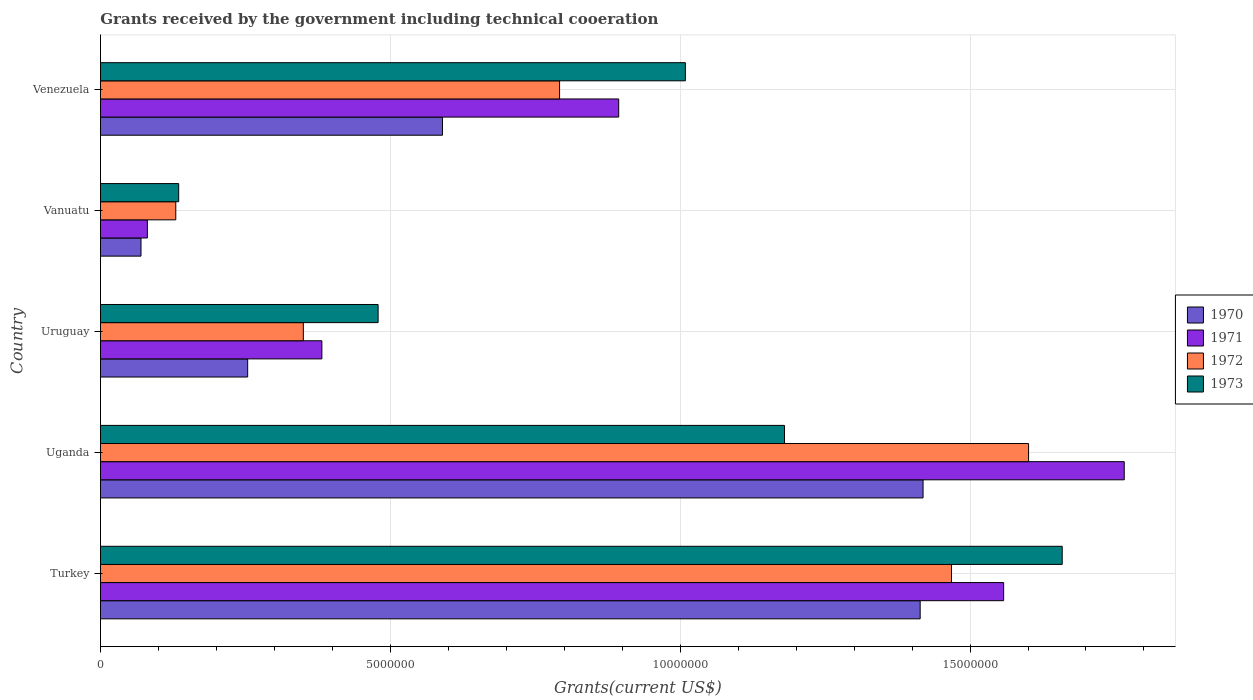How many groups of bars are there?
Make the answer very short. 5. Are the number of bars per tick equal to the number of legend labels?
Provide a short and direct response. Yes. How many bars are there on the 2nd tick from the top?
Offer a terse response. 4. How many bars are there on the 5th tick from the bottom?
Your answer should be very brief. 4. What is the label of the 2nd group of bars from the top?
Your answer should be very brief. Vanuatu. What is the total grants received by the government in 1973 in Turkey?
Offer a very short reply. 1.66e+07. Across all countries, what is the maximum total grants received by the government in 1971?
Your answer should be very brief. 1.77e+07. Across all countries, what is the minimum total grants received by the government in 1972?
Keep it short and to the point. 1.30e+06. In which country was the total grants received by the government in 1971 maximum?
Keep it short and to the point. Uganda. In which country was the total grants received by the government in 1970 minimum?
Give a very brief answer. Vanuatu. What is the total total grants received by the government in 1971 in the graph?
Provide a short and direct response. 4.68e+07. What is the difference between the total grants received by the government in 1971 in Uruguay and that in Venezuela?
Provide a short and direct response. -5.12e+06. What is the difference between the total grants received by the government in 1971 in Turkey and the total grants received by the government in 1972 in Uganda?
Provide a succinct answer. -4.30e+05. What is the average total grants received by the government in 1970 per country?
Offer a very short reply. 7.49e+06. What is the difference between the total grants received by the government in 1972 and total grants received by the government in 1970 in Uganda?
Your response must be concise. 1.82e+06. In how many countries, is the total grants received by the government in 1970 greater than 2000000 US$?
Your answer should be very brief. 4. What is the ratio of the total grants received by the government in 1970 in Uganda to that in Venezuela?
Offer a very short reply. 2.41. What is the difference between the highest and the second highest total grants received by the government in 1971?
Keep it short and to the point. 2.08e+06. What is the difference between the highest and the lowest total grants received by the government in 1973?
Ensure brevity in your answer.  1.52e+07. In how many countries, is the total grants received by the government in 1973 greater than the average total grants received by the government in 1973 taken over all countries?
Provide a succinct answer. 3. Is the sum of the total grants received by the government in 1973 in Turkey and Venezuela greater than the maximum total grants received by the government in 1971 across all countries?
Offer a very short reply. Yes. Are all the bars in the graph horizontal?
Your answer should be compact. Yes. How many countries are there in the graph?
Provide a succinct answer. 5. What is the difference between two consecutive major ticks on the X-axis?
Your answer should be very brief. 5.00e+06. Are the values on the major ticks of X-axis written in scientific E-notation?
Ensure brevity in your answer.  No. How many legend labels are there?
Keep it short and to the point. 4. How are the legend labels stacked?
Your answer should be compact. Vertical. What is the title of the graph?
Your answer should be compact. Grants received by the government including technical cooeration. Does "2001" appear as one of the legend labels in the graph?
Your answer should be very brief. No. What is the label or title of the X-axis?
Ensure brevity in your answer.  Grants(current US$). What is the label or title of the Y-axis?
Your answer should be very brief. Country. What is the Grants(current US$) in 1970 in Turkey?
Your answer should be very brief. 1.41e+07. What is the Grants(current US$) of 1971 in Turkey?
Keep it short and to the point. 1.56e+07. What is the Grants(current US$) of 1972 in Turkey?
Your answer should be very brief. 1.47e+07. What is the Grants(current US$) in 1973 in Turkey?
Make the answer very short. 1.66e+07. What is the Grants(current US$) in 1970 in Uganda?
Offer a very short reply. 1.42e+07. What is the Grants(current US$) of 1971 in Uganda?
Make the answer very short. 1.77e+07. What is the Grants(current US$) of 1972 in Uganda?
Make the answer very short. 1.60e+07. What is the Grants(current US$) of 1973 in Uganda?
Your answer should be very brief. 1.18e+07. What is the Grants(current US$) in 1970 in Uruguay?
Provide a short and direct response. 2.54e+06. What is the Grants(current US$) in 1971 in Uruguay?
Offer a terse response. 3.82e+06. What is the Grants(current US$) in 1972 in Uruguay?
Your answer should be very brief. 3.50e+06. What is the Grants(current US$) of 1973 in Uruguay?
Keep it short and to the point. 4.79e+06. What is the Grants(current US$) of 1970 in Vanuatu?
Your response must be concise. 7.00e+05. What is the Grants(current US$) of 1971 in Vanuatu?
Your response must be concise. 8.10e+05. What is the Grants(current US$) in 1972 in Vanuatu?
Provide a short and direct response. 1.30e+06. What is the Grants(current US$) in 1973 in Vanuatu?
Provide a short and direct response. 1.35e+06. What is the Grants(current US$) in 1970 in Venezuela?
Keep it short and to the point. 5.90e+06. What is the Grants(current US$) in 1971 in Venezuela?
Provide a short and direct response. 8.94e+06. What is the Grants(current US$) of 1972 in Venezuela?
Provide a succinct answer. 7.92e+06. What is the Grants(current US$) of 1973 in Venezuela?
Provide a succinct answer. 1.01e+07. Across all countries, what is the maximum Grants(current US$) in 1970?
Offer a terse response. 1.42e+07. Across all countries, what is the maximum Grants(current US$) of 1971?
Offer a very short reply. 1.77e+07. Across all countries, what is the maximum Grants(current US$) in 1972?
Give a very brief answer. 1.60e+07. Across all countries, what is the maximum Grants(current US$) of 1973?
Give a very brief answer. 1.66e+07. Across all countries, what is the minimum Grants(current US$) in 1971?
Offer a terse response. 8.10e+05. Across all countries, what is the minimum Grants(current US$) in 1972?
Provide a short and direct response. 1.30e+06. Across all countries, what is the minimum Grants(current US$) of 1973?
Your answer should be very brief. 1.35e+06. What is the total Grants(current US$) of 1970 in the graph?
Ensure brevity in your answer.  3.75e+07. What is the total Grants(current US$) in 1971 in the graph?
Your answer should be compact. 4.68e+07. What is the total Grants(current US$) of 1972 in the graph?
Provide a short and direct response. 4.34e+07. What is the total Grants(current US$) of 1973 in the graph?
Offer a terse response. 4.46e+07. What is the difference between the Grants(current US$) in 1971 in Turkey and that in Uganda?
Make the answer very short. -2.08e+06. What is the difference between the Grants(current US$) in 1972 in Turkey and that in Uganda?
Provide a succinct answer. -1.33e+06. What is the difference between the Grants(current US$) of 1973 in Turkey and that in Uganda?
Ensure brevity in your answer.  4.79e+06. What is the difference between the Grants(current US$) in 1970 in Turkey and that in Uruguay?
Offer a very short reply. 1.16e+07. What is the difference between the Grants(current US$) in 1971 in Turkey and that in Uruguay?
Offer a very short reply. 1.18e+07. What is the difference between the Grants(current US$) in 1972 in Turkey and that in Uruguay?
Ensure brevity in your answer.  1.12e+07. What is the difference between the Grants(current US$) of 1973 in Turkey and that in Uruguay?
Ensure brevity in your answer.  1.18e+07. What is the difference between the Grants(current US$) of 1970 in Turkey and that in Vanuatu?
Keep it short and to the point. 1.34e+07. What is the difference between the Grants(current US$) in 1971 in Turkey and that in Vanuatu?
Offer a terse response. 1.48e+07. What is the difference between the Grants(current US$) of 1972 in Turkey and that in Vanuatu?
Your answer should be compact. 1.34e+07. What is the difference between the Grants(current US$) in 1973 in Turkey and that in Vanuatu?
Your response must be concise. 1.52e+07. What is the difference between the Grants(current US$) of 1970 in Turkey and that in Venezuela?
Offer a very short reply. 8.24e+06. What is the difference between the Grants(current US$) of 1971 in Turkey and that in Venezuela?
Ensure brevity in your answer.  6.64e+06. What is the difference between the Grants(current US$) of 1972 in Turkey and that in Venezuela?
Your answer should be very brief. 6.76e+06. What is the difference between the Grants(current US$) of 1973 in Turkey and that in Venezuela?
Your answer should be very brief. 6.50e+06. What is the difference between the Grants(current US$) in 1970 in Uganda and that in Uruguay?
Give a very brief answer. 1.16e+07. What is the difference between the Grants(current US$) of 1971 in Uganda and that in Uruguay?
Make the answer very short. 1.38e+07. What is the difference between the Grants(current US$) in 1972 in Uganda and that in Uruguay?
Your answer should be compact. 1.25e+07. What is the difference between the Grants(current US$) in 1973 in Uganda and that in Uruguay?
Offer a terse response. 7.01e+06. What is the difference between the Grants(current US$) in 1970 in Uganda and that in Vanuatu?
Ensure brevity in your answer.  1.35e+07. What is the difference between the Grants(current US$) in 1971 in Uganda and that in Vanuatu?
Give a very brief answer. 1.68e+07. What is the difference between the Grants(current US$) of 1972 in Uganda and that in Vanuatu?
Give a very brief answer. 1.47e+07. What is the difference between the Grants(current US$) in 1973 in Uganda and that in Vanuatu?
Provide a succinct answer. 1.04e+07. What is the difference between the Grants(current US$) of 1970 in Uganda and that in Venezuela?
Make the answer very short. 8.29e+06. What is the difference between the Grants(current US$) in 1971 in Uganda and that in Venezuela?
Ensure brevity in your answer.  8.72e+06. What is the difference between the Grants(current US$) of 1972 in Uganda and that in Venezuela?
Your response must be concise. 8.09e+06. What is the difference between the Grants(current US$) in 1973 in Uganda and that in Venezuela?
Offer a terse response. 1.71e+06. What is the difference between the Grants(current US$) in 1970 in Uruguay and that in Vanuatu?
Provide a succinct answer. 1.84e+06. What is the difference between the Grants(current US$) in 1971 in Uruguay and that in Vanuatu?
Keep it short and to the point. 3.01e+06. What is the difference between the Grants(current US$) of 1972 in Uruguay and that in Vanuatu?
Keep it short and to the point. 2.20e+06. What is the difference between the Grants(current US$) in 1973 in Uruguay and that in Vanuatu?
Offer a very short reply. 3.44e+06. What is the difference between the Grants(current US$) of 1970 in Uruguay and that in Venezuela?
Ensure brevity in your answer.  -3.36e+06. What is the difference between the Grants(current US$) of 1971 in Uruguay and that in Venezuela?
Make the answer very short. -5.12e+06. What is the difference between the Grants(current US$) in 1972 in Uruguay and that in Venezuela?
Make the answer very short. -4.42e+06. What is the difference between the Grants(current US$) of 1973 in Uruguay and that in Venezuela?
Offer a terse response. -5.30e+06. What is the difference between the Grants(current US$) of 1970 in Vanuatu and that in Venezuela?
Provide a succinct answer. -5.20e+06. What is the difference between the Grants(current US$) of 1971 in Vanuatu and that in Venezuela?
Ensure brevity in your answer.  -8.13e+06. What is the difference between the Grants(current US$) in 1972 in Vanuatu and that in Venezuela?
Give a very brief answer. -6.62e+06. What is the difference between the Grants(current US$) of 1973 in Vanuatu and that in Venezuela?
Your response must be concise. -8.74e+06. What is the difference between the Grants(current US$) in 1970 in Turkey and the Grants(current US$) in 1971 in Uganda?
Provide a succinct answer. -3.52e+06. What is the difference between the Grants(current US$) of 1970 in Turkey and the Grants(current US$) of 1972 in Uganda?
Provide a succinct answer. -1.87e+06. What is the difference between the Grants(current US$) of 1970 in Turkey and the Grants(current US$) of 1973 in Uganda?
Offer a very short reply. 2.34e+06. What is the difference between the Grants(current US$) in 1971 in Turkey and the Grants(current US$) in 1972 in Uganda?
Ensure brevity in your answer.  -4.30e+05. What is the difference between the Grants(current US$) in 1971 in Turkey and the Grants(current US$) in 1973 in Uganda?
Your response must be concise. 3.78e+06. What is the difference between the Grants(current US$) of 1972 in Turkey and the Grants(current US$) of 1973 in Uganda?
Provide a short and direct response. 2.88e+06. What is the difference between the Grants(current US$) of 1970 in Turkey and the Grants(current US$) of 1971 in Uruguay?
Give a very brief answer. 1.03e+07. What is the difference between the Grants(current US$) in 1970 in Turkey and the Grants(current US$) in 1972 in Uruguay?
Give a very brief answer. 1.06e+07. What is the difference between the Grants(current US$) in 1970 in Turkey and the Grants(current US$) in 1973 in Uruguay?
Your response must be concise. 9.35e+06. What is the difference between the Grants(current US$) in 1971 in Turkey and the Grants(current US$) in 1972 in Uruguay?
Give a very brief answer. 1.21e+07. What is the difference between the Grants(current US$) of 1971 in Turkey and the Grants(current US$) of 1973 in Uruguay?
Offer a very short reply. 1.08e+07. What is the difference between the Grants(current US$) in 1972 in Turkey and the Grants(current US$) in 1973 in Uruguay?
Your response must be concise. 9.89e+06. What is the difference between the Grants(current US$) in 1970 in Turkey and the Grants(current US$) in 1971 in Vanuatu?
Provide a succinct answer. 1.33e+07. What is the difference between the Grants(current US$) of 1970 in Turkey and the Grants(current US$) of 1972 in Vanuatu?
Keep it short and to the point. 1.28e+07. What is the difference between the Grants(current US$) in 1970 in Turkey and the Grants(current US$) in 1973 in Vanuatu?
Your answer should be very brief. 1.28e+07. What is the difference between the Grants(current US$) of 1971 in Turkey and the Grants(current US$) of 1972 in Vanuatu?
Offer a terse response. 1.43e+07. What is the difference between the Grants(current US$) in 1971 in Turkey and the Grants(current US$) in 1973 in Vanuatu?
Give a very brief answer. 1.42e+07. What is the difference between the Grants(current US$) of 1972 in Turkey and the Grants(current US$) of 1973 in Vanuatu?
Provide a succinct answer. 1.33e+07. What is the difference between the Grants(current US$) in 1970 in Turkey and the Grants(current US$) in 1971 in Venezuela?
Provide a short and direct response. 5.20e+06. What is the difference between the Grants(current US$) in 1970 in Turkey and the Grants(current US$) in 1972 in Venezuela?
Keep it short and to the point. 6.22e+06. What is the difference between the Grants(current US$) in 1970 in Turkey and the Grants(current US$) in 1973 in Venezuela?
Keep it short and to the point. 4.05e+06. What is the difference between the Grants(current US$) in 1971 in Turkey and the Grants(current US$) in 1972 in Venezuela?
Your answer should be very brief. 7.66e+06. What is the difference between the Grants(current US$) of 1971 in Turkey and the Grants(current US$) of 1973 in Venezuela?
Your response must be concise. 5.49e+06. What is the difference between the Grants(current US$) in 1972 in Turkey and the Grants(current US$) in 1973 in Venezuela?
Offer a terse response. 4.59e+06. What is the difference between the Grants(current US$) in 1970 in Uganda and the Grants(current US$) in 1971 in Uruguay?
Offer a very short reply. 1.04e+07. What is the difference between the Grants(current US$) in 1970 in Uganda and the Grants(current US$) in 1972 in Uruguay?
Your answer should be very brief. 1.07e+07. What is the difference between the Grants(current US$) of 1970 in Uganda and the Grants(current US$) of 1973 in Uruguay?
Your response must be concise. 9.40e+06. What is the difference between the Grants(current US$) of 1971 in Uganda and the Grants(current US$) of 1972 in Uruguay?
Make the answer very short. 1.42e+07. What is the difference between the Grants(current US$) in 1971 in Uganda and the Grants(current US$) in 1973 in Uruguay?
Ensure brevity in your answer.  1.29e+07. What is the difference between the Grants(current US$) of 1972 in Uganda and the Grants(current US$) of 1973 in Uruguay?
Provide a short and direct response. 1.12e+07. What is the difference between the Grants(current US$) of 1970 in Uganda and the Grants(current US$) of 1971 in Vanuatu?
Make the answer very short. 1.34e+07. What is the difference between the Grants(current US$) in 1970 in Uganda and the Grants(current US$) in 1972 in Vanuatu?
Your response must be concise. 1.29e+07. What is the difference between the Grants(current US$) of 1970 in Uganda and the Grants(current US$) of 1973 in Vanuatu?
Offer a very short reply. 1.28e+07. What is the difference between the Grants(current US$) in 1971 in Uganda and the Grants(current US$) in 1972 in Vanuatu?
Offer a terse response. 1.64e+07. What is the difference between the Grants(current US$) in 1971 in Uganda and the Grants(current US$) in 1973 in Vanuatu?
Provide a succinct answer. 1.63e+07. What is the difference between the Grants(current US$) in 1972 in Uganda and the Grants(current US$) in 1973 in Vanuatu?
Provide a short and direct response. 1.47e+07. What is the difference between the Grants(current US$) in 1970 in Uganda and the Grants(current US$) in 1971 in Venezuela?
Keep it short and to the point. 5.25e+06. What is the difference between the Grants(current US$) in 1970 in Uganda and the Grants(current US$) in 1972 in Venezuela?
Ensure brevity in your answer.  6.27e+06. What is the difference between the Grants(current US$) of 1970 in Uganda and the Grants(current US$) of 1973 in Venezuela?
Make the answer very short. 4.10e+06. What is the difference between the Grants(current US$) of 1971 in Uganda and the Grants(current US$) of 1972 in Venezuela?
Offer a very short reply. 9.74e+06. What is the difference between the Grants(current US$) in 1971 in Uganda and the Grants(current US$) in 1973 in Venezuela?
Give a very brief answer. 7.57e+06. What is the difference between the Grants(current US$) in 1972 in Uganda and the Grants(current US$) in 1973 in Venezuela?
Make the answer very short. 5.92e+06. What is the difference between the Grants(current US$) in 1970 in Uruguay and the Grants(current US$) in 1971 in Vanuatu?
Keep it short and to the point. 1.73e+06. What is the difference between the Grants(current US$) of 1970 in Uruguay and the Grants(current US$) of 1972 in Vanuatu?
Offer a terse response. 1.24e+06. What is the difference between the Grants(current US$) of 1970 in Uruguay and the Grants(current US$) of 1973 in Vanuatu?
Your response must be concise. 1.19e+06. What is the difference between the Grants(current US$) of 1971 in Uruguay and the Grants(current US$) of 1972 in Vanuatu?
Offer a terse response. 2.52e+06. What is the difference between the Grants(current US$) in 1971 in Uruguay and the Grants(current US$) in 1973 in Vanuatu?
Ensure brevity in your answer.  2.47e+06. What is the difference between the Grants(current US$) in 1972 in Uruguay and the Grants(current US$) in 1973 in Vanuatu?
Your response must be concise. 2.15e+06. What is the difference between the Grants(current US$) in 1970 in Uruguay and the Grants(current US$) in 1971 in Venezuela?
Provide a short and direct response. -6.40e+06. What is the difference between the Grants(current US$) of 1970 in Uruguay and the Grants(current US$) of 1972 in Venezuela?
Your answer should be compact. -5.38e+06. What is the difference between the Grants(current US$) in 1970 in Uruguay and the Grants(current US$) in 1973 in Venezuela?
Make the answer very short. -7.55e+06. What is the difference between the Grants(current US$) in 1971 in Uruguay and the Grants(current US$) in 1972 in Venezuela?
Provide a short and direct response. -4.10e+06. What is the difference between the Grants(current US$) in 1971 in Uruguay and the Grants(current US$) in 1973 in Venezuela?
Your answer should be compact. -6.27e+06. What is the difference between the Grants(current US$) of 1972 in Uruguay and the Grants(current US$) of 1973 in Venezuela?
Provide a succinct answer. -6.59e+06. What is the difference between the Grants(current US$) of 1970 in Vanuatu and the Grants(current US$) of 1971 in Venezuela?
Offer a very short reply. -8.24e+06. What is the difference between the Grants(current US$) in 1970 in Vanuatu and the Grants(current US$) in 1972 in Venezuela?
Keep it short and to the point. -7.22e+06. What is the difference between the Grants(current US$) in 1970 in Vanuatu and the Grants(current US$) in 1973 in Venezuela?
Your answer should be compact. -9.39e+06. What is the difference between the Grants(current US$) of 1971 in Vanuatu and the Grants(current US$) of 1972 in Venezuela?
Provide a succinct answer. -7.11e+06. What is the difference between the Grants(current US$) in 1971 in Vanuatu and the Grants(current US$) in 1973 in Venezuela?
Offer a terse response. -9.28e+06. What is the difference between the Grants(current US$) of 1972 in Vanuatu and the Grants(current US$) of 1973 in Venezuela?
Your answer should be compact. -8.79e+06. What is the average Grants(current US$) of 1970 per country?
Give a very brief answer. 7.49e+06. What is the average Grants(current US$) in 1971 per country?
Make the answer very short. 9.36e+06. What is the average Grants(current US$) in 1972 per country?
Provide a short and direct response. 8.68e+06. What is the average Grants(current US$) in 1973 per country?
Ensure brevity in your answer.  8.92e+06. What is the difference between the Grants(current US$) of 1970 and Grants(current US$) of 1971 in Turkey?
Your response must be concise. -1.44e+06. What is the difference between the Grants(current US$) of 1970 and Grants(current US$) of 1972 in Turkey?
Give a very brief answer. -5.40e+05. What is the difference between the Grants(current US$) of 1970 and Grants(current US$) of 1973 in Turkey?
Offer a very short reply. -2.45e+06. What is the difference between the Grants(current US$) in 1971 and Grants(current US$) in 1973 in Turkey?
Give a very brief answer. -1.01e+06. What is the difference between the Grants(current US$) in 1972 and Grants(current US$) in 1973 in Turkey?
Provide a short and direct response. -1.91e+06. What is the difference between the Grants(current US$) in 1970 and Grants(current US$) in 1971 in Uganda?
Offer a terse response. -3.47e+06. What is the difference between the Grants(current US$) of 1970 and Grants(current US$) of 1972 in Uganda?
Offer a very short reply. -1.82e+06. What is the difference between the Grants(current US$) in 1970 and Grants(current US$) in 1973 in Uganda?
Keep it short and to the point. 2.39e+06. What is the difference between the Grants(current US$) of 1971 and Grants(current US$) of 1972 in Uganda?
Make the answer very short. 1.65e+06. What is the difference between the Grants(current US$) of 1971 and Grants(current US$) of 1973 in Uganda?
Your answer should be compact. 5.86e+06. What is the difference between the Grants(current US$) of 1972 and Grants(current US$) of 1973 in Uganda?
Provide a short and direct response. 4.21e+06. What is the difference between the Grants(current US$) of 1970 and Grants(current US$) of 1971 in Uruguay?
Keep it short and to the point. -1.28e+06. What is the difference between the Grants(current US$) in 1970 and Grants(current US$) in 1972 in Uruguay?
Provide a succinct answer. -9.60e+05. What is the difference between the Grants(current US$) in 1970 and Grants(current US$) in 1973 in Uruguay?
Your response must be concise. -2.25e+06. What is the difference between the Grants(current US$) of 1971 and Grants(current US$) of 1972 in Uruguay?
Offer a very short reply. 3.20e+05. What is the difference between the Grants(current US$) in 1971 and Grants(current US$) in 1973 in Uruguay?
Keep it short and to the point. -9.70e+05. What is the difference between the Grants(current US$) in 1972 and Grants(current US$) in 1973 in Uruguay?
Make the answer very short. -1.29e+06. What is the difference between the Grants(current US$) of 1970 and Grants(current US$) of 1971 in Vanuatu?
Make the answer very short. -1.10e+05. What is the difference between the Grants(current US$) of 1970 and Grants(current US$) of 1972 in Vanuatu?
Offer a very short reply. -6.00e+05. What is the difference between the Grants(current US$) in 1970 and Grants(current US$) in 1973 in Vanuatu?
Keep it short and to the point. -6.50e+05. What is the difference between the Grants(current US$) in 1971 and Grants(current US$) in 1972 in Vanuatu?
Offer a very short reply. -4.90e+05. What is the difference between the Grants(current US$) in 1971 and Grants(current US$) in 1973 in Vanuatu?
Ensure brevity in your answer.  -5.40e+05. What is the difference between the Grants(current US$) in 1970 and Grants(current US$) in 1971 in Venezuela?
Make the answer very short. -3.04e+06. What is the difference between the Grants(current US$) in 1970 and Grants(current US$) in 1972 in Venezuela?
Keep it short and to the point. -2.02e+06. What is the difference between the Grants(current US$) of 1970 and Grants(current US$) of 1973 in Venezuela?
Offer a very short reply. -4.19e+06. What is the difference between the Grants(current US$) in 1971 and Grants(current US$) in 1972 in Venezuela?
Your response must be concise. 1.02e+06. What is the difference between the Grants(current US$) in 1971 and Grants(current US$) in 1973 in Venezuela?
Provide a succinct answer. -1.15e+06. What is the difference between the Grants(current US$) of 1972 and Grants(current US$) of 1973 in Venezuela?
Your response must be concise. -2.17e+06. What is the ratio of the Grants(current US$) of 1971 in Turkey to that in Uganda?
Provide a succinct answer. 0.88. What is the ratio of the Grants(current US$) of 1972 in Turkey to that in Uganda?
Keep it short and to the point. 0.92. What is the ratio of the Grants(current US$) in 1973 in Turkey to that in Uganda?
Your answer should be compact. 1.41. What is the ratio of the Grants(current US$) of 1970 in Turkey to that in Uruguay?
Offer a very short reply. 5.57. What is the ratio of the Grants(current US$) in 1971 in Turkey to that in Uruguay?
Make the answer very short. 4.08. What is the ratio of the Grants(current US$) of 1972 in Turkey to that in Uruguay?
Your response must be concise. 4.19. What is the ratio of the Grants(current US$) in 1973 in Turkey to that in Uruguay?
Provide a succinct answer. 3.46. What is the ratio of the Grants(current US$) in 1970 in Turkey to that in Vanuatu?
Offer a terse response. 20.2. What is the ratio of the Grants(current US$) of 1971 in Turkey to that in Vanuatu?
Keep it short and to the point. 19.23. What is the ratio of the Grants(current US$) in 1972 in Turkey to that in Vanuatu?
Offer a terse response. 11.29. What is the ratio of the Grants(current US$) of 1973 in Turkey to that in Vanuatu?
Your answer should be compact. 12.29. What is the ratio of the Grants(current US$) of 1970 in Turkey to that in Venezuela?
Provide a succinct answer. 2.4. What is the ratio of the Grants(current US$) of 1971 in Turkey to that in Venezuela?
Your answer should be compact. 1.74. What is the ratio of the Grants(current US$) in 1972 in Turkey to that in Venezuela?
Offer a very short reply. 1.85. What is the ratio of the Grants(current US$) in 1973 in Turkey to that in Venezuela?
Your response must be concise. 1.64. What is the ratio of the Grants(current US$) of 1970 in Uganda to that in Uruguay?
Your answer should be compact. 5.59. What is the ratio of the Grants(current US$) in 1971 in Uganda to that in Uruguay?
Offer a terse response. 4.62. What is the ratio of the Grants(current US$) of 1972 in Uganda to that in Uruguay?
Provide a short and direct response. 4.57. What is the ratio of the Grants(current US$) of 1973 in Uganda to that in Uruguay?
Make the answer very short. 2.46. What is the ratio of the Grants(current US$) in 1970 in Uganda to that in Vanuatu?
Give a very brief answer. 20.27. What is the ratio of the Grants(current US$) in 1971 in Uganda to that in Vanuatu?
Provide a short and direct response. 21.8. What is the ratio of the Grants(current US$) of 1972 in Uganda to that in Vanuatu?
Offer a very short reply. 12.32. What is the ratio of the Grants(current US$) in 1973 in Uganda to that in Vanuatu?
Your answer should be compact. 8.74. What is the ratio of the Grants(current US$) in 1970 in Uganda to that in Venezuela?
Keep it short and to the point. 2.41. What is the ratio of the Grants(current US$) of 1971 in Uganda to that in Venezuela?
Offer a very short reply. 1.98. What is the ratio of the Grants(current US$) of 1972 in Uganda to that in Venezuela?
Offer a terse response. 2.02. What is the ratio of the Grants(current US$) of 1973 in Uganda to that in Venezuela?
Your answer should be very brief. 1.17. What is the ratio of the Grants(current US$) of 1970 in Uruguay to that in Vanuatu?
Your response must be concise. 3.63. What is the ratio of the Grants(current US$) of 1971 in Uruguay to that in Vanuatu?
Provide a succinct answer. 4.72. What is the ratio of the Grants(current US$) in 1972 in Uruguay to that in Vanuatu?
Ensure brevity in your answer.  2.69. What is the ratio of the Grants(current US$) in 1973 in Uruguay to that in Vanuatu?
Your response must be concise. 3.55. What is the ratio of the Grants(current US$) of 1970 in Uruguay to that in Venezuela?
Give a very brief answer. 0.43. What is the ratio of the Grants(current US$) in 1971 in Uruguay to that in Venezuela?
Your answer should be compact. 0.43. What is the ratio of the Grants(current US$) of 1972 in Uruguay to that in Venezuela?
Offer a very short reply. 0.44. What is the ratio of the Grants(current US$) of 1973 in Uruguay to that in Venezuela?
Provide a succinct answer. 0.47. What is the ratio of the Grants(current US$) in 1970 in Vanuatu to that in Venezuela?
Ensure brevity in your answer.  0.12. What is the ratio of the Grants(current US$) of 1971 in Vanuatu to that in Venezuela?
Your answer should be compact. 0.09. What is the ratio of the Grants(current US$) of 1972 in Vanuatu to that in Venezuela?
Your response must be concise. 0.16. What is the ratio of the Grants(current US$) in 1973 in Vanuatu to that in Venezuela?
Provide a short and direct response. 0.13. What is the difference between the highest and the second highest Grants(current US$) in 1970?
Ensure brevity in your answer.  5.00e+04. What is the difference between the highest and the second highest Grants(current US$) in 1971?
Offer a very short reply. 2.08e+06. What is the difference between the highest and the second highest Grants(current US$) in 1972?
Offer a terse response. 1.33e+06. What is the difference between the highest and the second highest Grants(current US$) in 1973?
Make the answer very short. 4.79e+06. What is the difference between the highest and the lowest Grants(current US$) of 1970?
Provide a succinct answer. 1.35e+07. What is the difference between the highest and the lowest Grants(current US$) of 1971?
Give a very brief answer. 1.68e+07. What is the difference between the highest and the lowest Grants(current US$) in 1972?
Offer a terse response. 1.47e+07. What is the difference between the highest and the lowest Grants(current US$) in 1973?
Keep it short and to the point. 1.52e+07. 